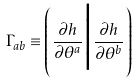Convert formula to latex. <formula><loc_0><loc_0><loc_500><loc_500>\Gamma _ { a b } \equiv \left ( \frac { \partial h } { \partial \theta ^ { a } } \Big | \frac { \partial h } { \partial \theta ^ { b } } \right )</formula> 